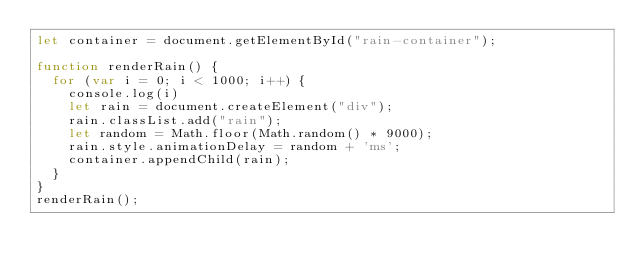<code> <loc_0><loc_0><loc_500><loc_500><_JavaScript_>let container = document.getElementById("rain-container");

function renderRain() {
  for (var i = 0; i < 1000; i++) {
    console.log(i)
    let rain = document.createElement("div");
    rain.classList.add("rain");
    let random = Math.floor(Math.random() * 9000);
    rain.style.animationDelay = random + 'ms';
    container.appendChild(rain);
  }
}
renderRain();
</code> 